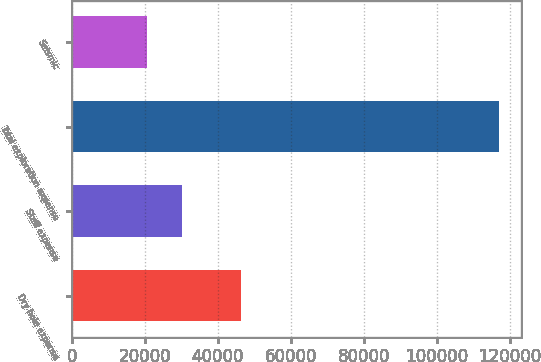<chart> <loc_0><loc_0><loc_500><loc_500><bar_chart><fcel>Dry hole expense<fcel>Staff expense<fcel>Total exploration expense<fcel>Seismic<nl><fcel>46192<fcel>30142.9<fcel>117001<fcel>20492<nl></chart> 